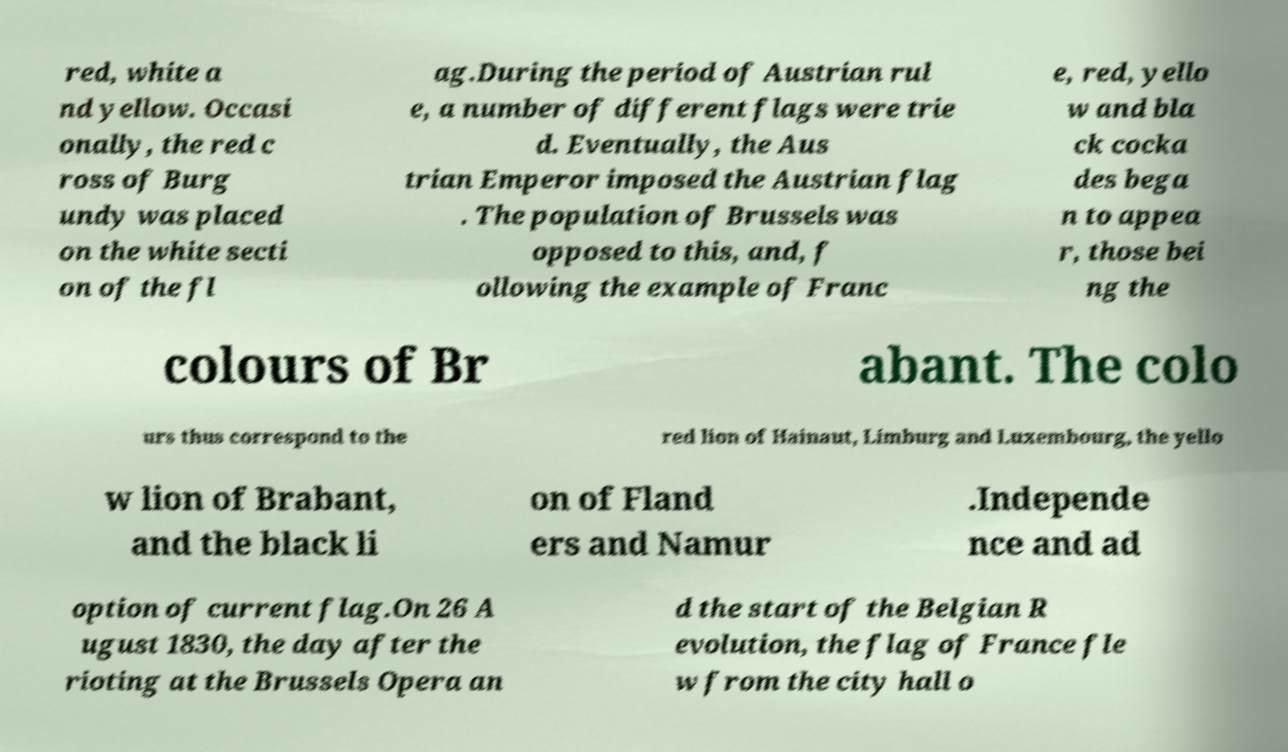Could you extract and type out the text from this image? red, white a nd yellow. Occasi onally, the red c ross of Burg undy was placed on the white secti on of the fl ag.During the period of Austrian rul e, a number of different flags were trie d. Eventually, the Aus trian Emperor imposed the Austrian flag . The population of Brussels was opposed to this, and, f ollowing the example of Franc e, red, yello w and bla ck cocka des bega n to appea r, those bei ng the colours of Br abant. The colo urs thus correspond to the red lion of Hainaut, Limburg and Luxembourg, the yello w lion of Brabant, and the black li on of Fland ers and Namur .Independe nce and ad option of current flag.On 26 A ugust 1830, the day after the rioting at the Brussels Opera an d the start of the Belgian R evolution, the flag of France fle w from the city hall o 